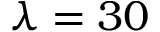Convert formula to latex. <formula><loc_0><loc_0><loc_500><loc_500>\lambda = 3 0</formula> 